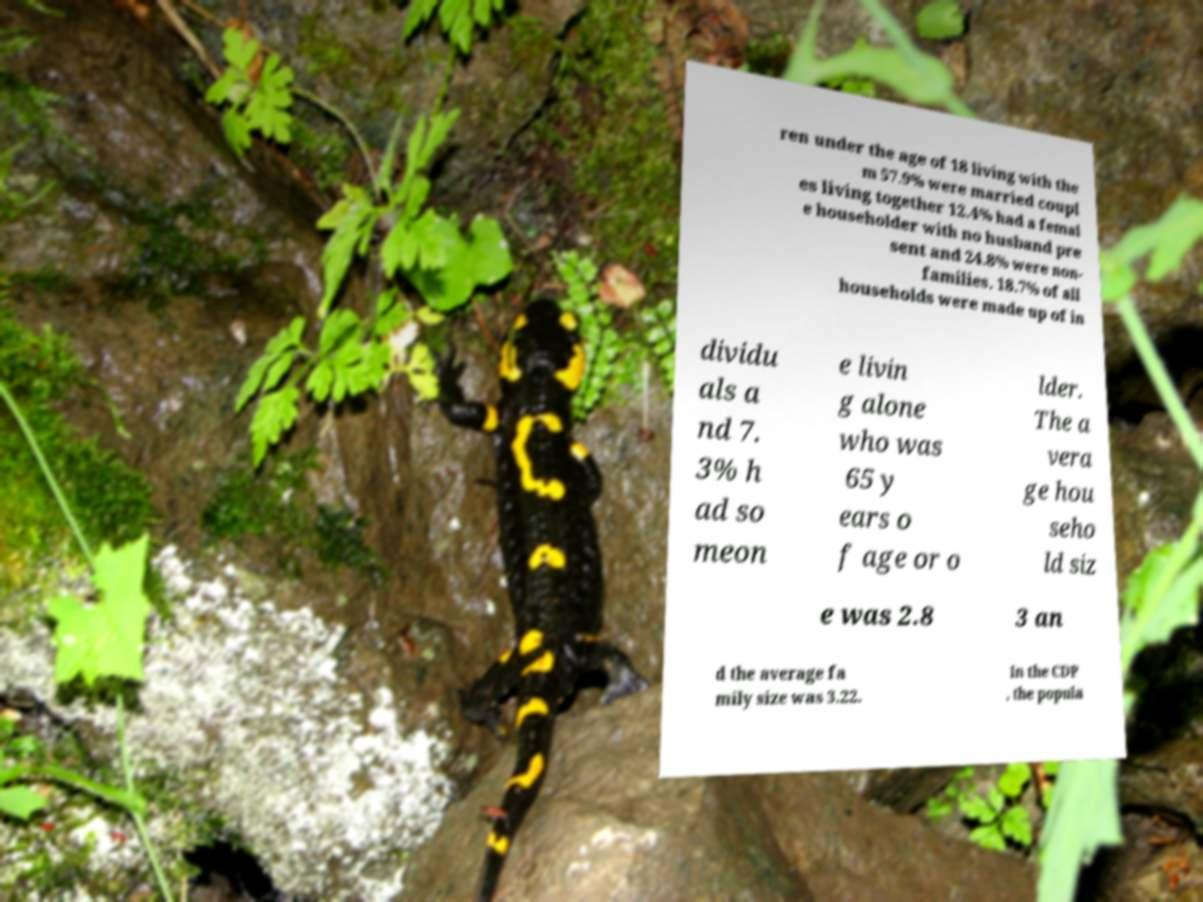Can you read and provide the text displayed in the image?This photo seems to have some interesting text. Can you extract and type it out for me? ren under the age of 18 living with the m 57.9% were married coupl es living together 12.4% had a femal e householder with no husband pre sent and 24.8% were non- families. 18.7% of all households were made up of in dividu als a nd 7. 3% h ad so meon e livin g alone who was 65 y ears o f age or o lder. The a vera ge hou seho ld siz e was 2.8 3 an d the average fa mily size was 3.22. In the CDP , the popula 